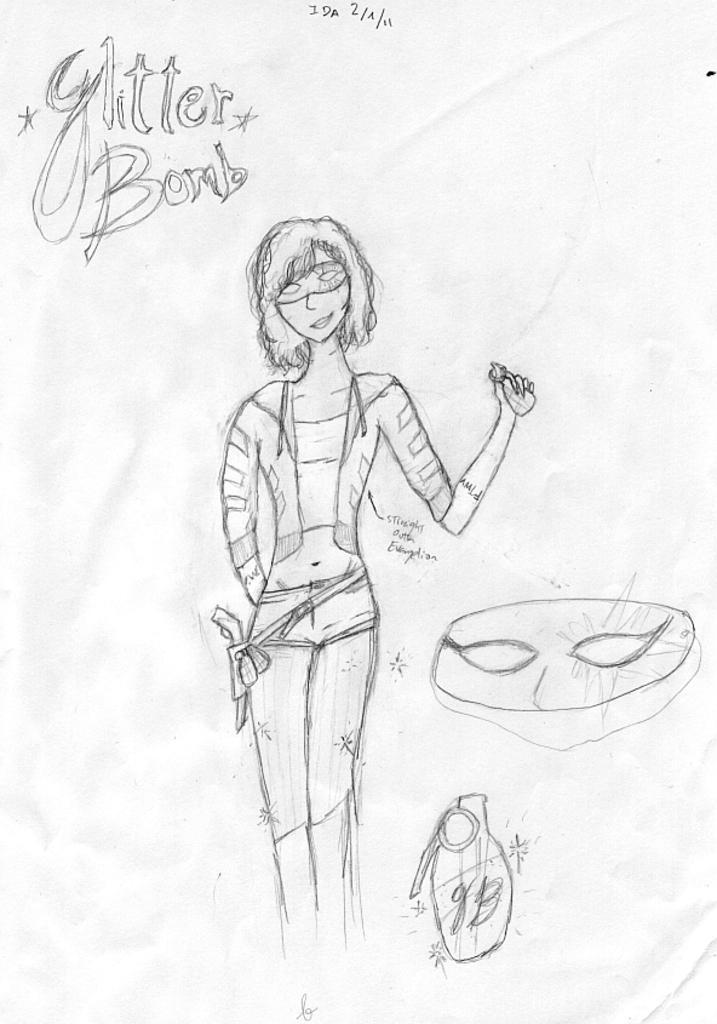Please provide a concise description of this image. In the image on the paper there is a drawing of a lady with a mask on the face and also there are some other things. And there is something written on the paper. 